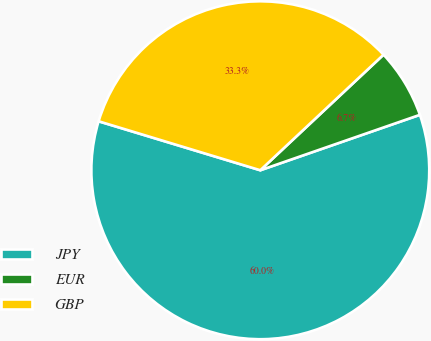<chart> <loc_0><loc_0><loc_500><loc_500><pie_chart><fcel>JPY<fcel>EUR<fcel>GBP<nl><fcel>60.0%<fcel>6.67%<fcel>33.33%<nl></chart> 